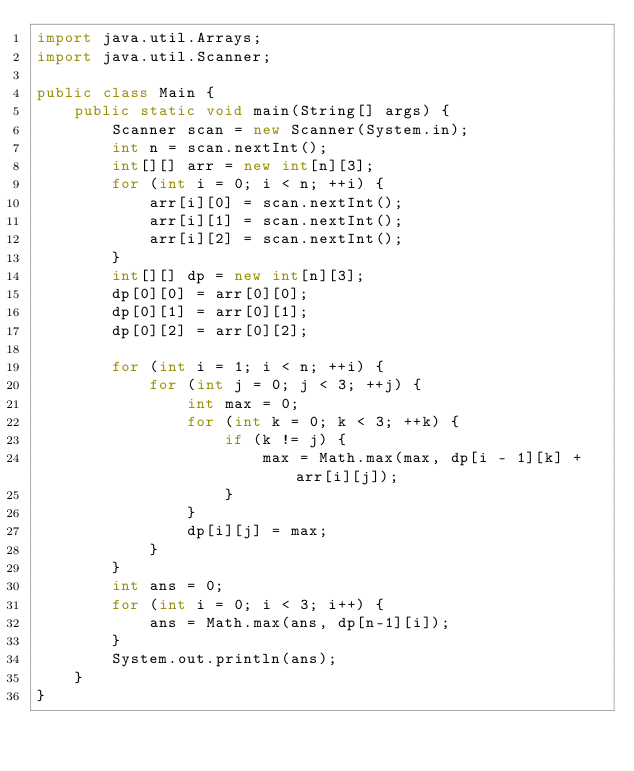Convert code to text. <code><loc_0><loc_0><loc_500><loc_500><_Java_>import java.util.Arrays;
import java.util.Scanner;

public class Main {
	public static void main(String[] args) {
		Scanner scan = new Scanner(System.in);
		int n = scan.nextInt();
		int[][] arr = new int[n][3];
		for (int i = 0; i < n; ++i) {
			arr[i][0] = scan.nextInt();
			arr[i][1] = scan.nextInt();
			arr[i][2] = scan.nextInt();
		}
		int[][] dp = new int[n][3];
		dp[0][0] = arr[0][0];
		dp[0][1] = arr[0][1];
		dp[0][2] = arr[0][2];

		for (int i = 1; i < n; ++i) {
			for (int j = 0; j < 3; ++j) {
				int max = 0;
				for (int k = 0; k < 3; ++k) {
					if (k != j) {
						max = Math.max(max, dp[i - 1][k] + arr[i][j]);
					}
				}
				dp[i][j] = max;
			}
		}
		int ans = 0;
		for (int i = 0; i < 3; i++) {
			ans = Math.max(ans, dp[n-1][i]);
		}
		System.out.println(ans);
	}
}
</code> 